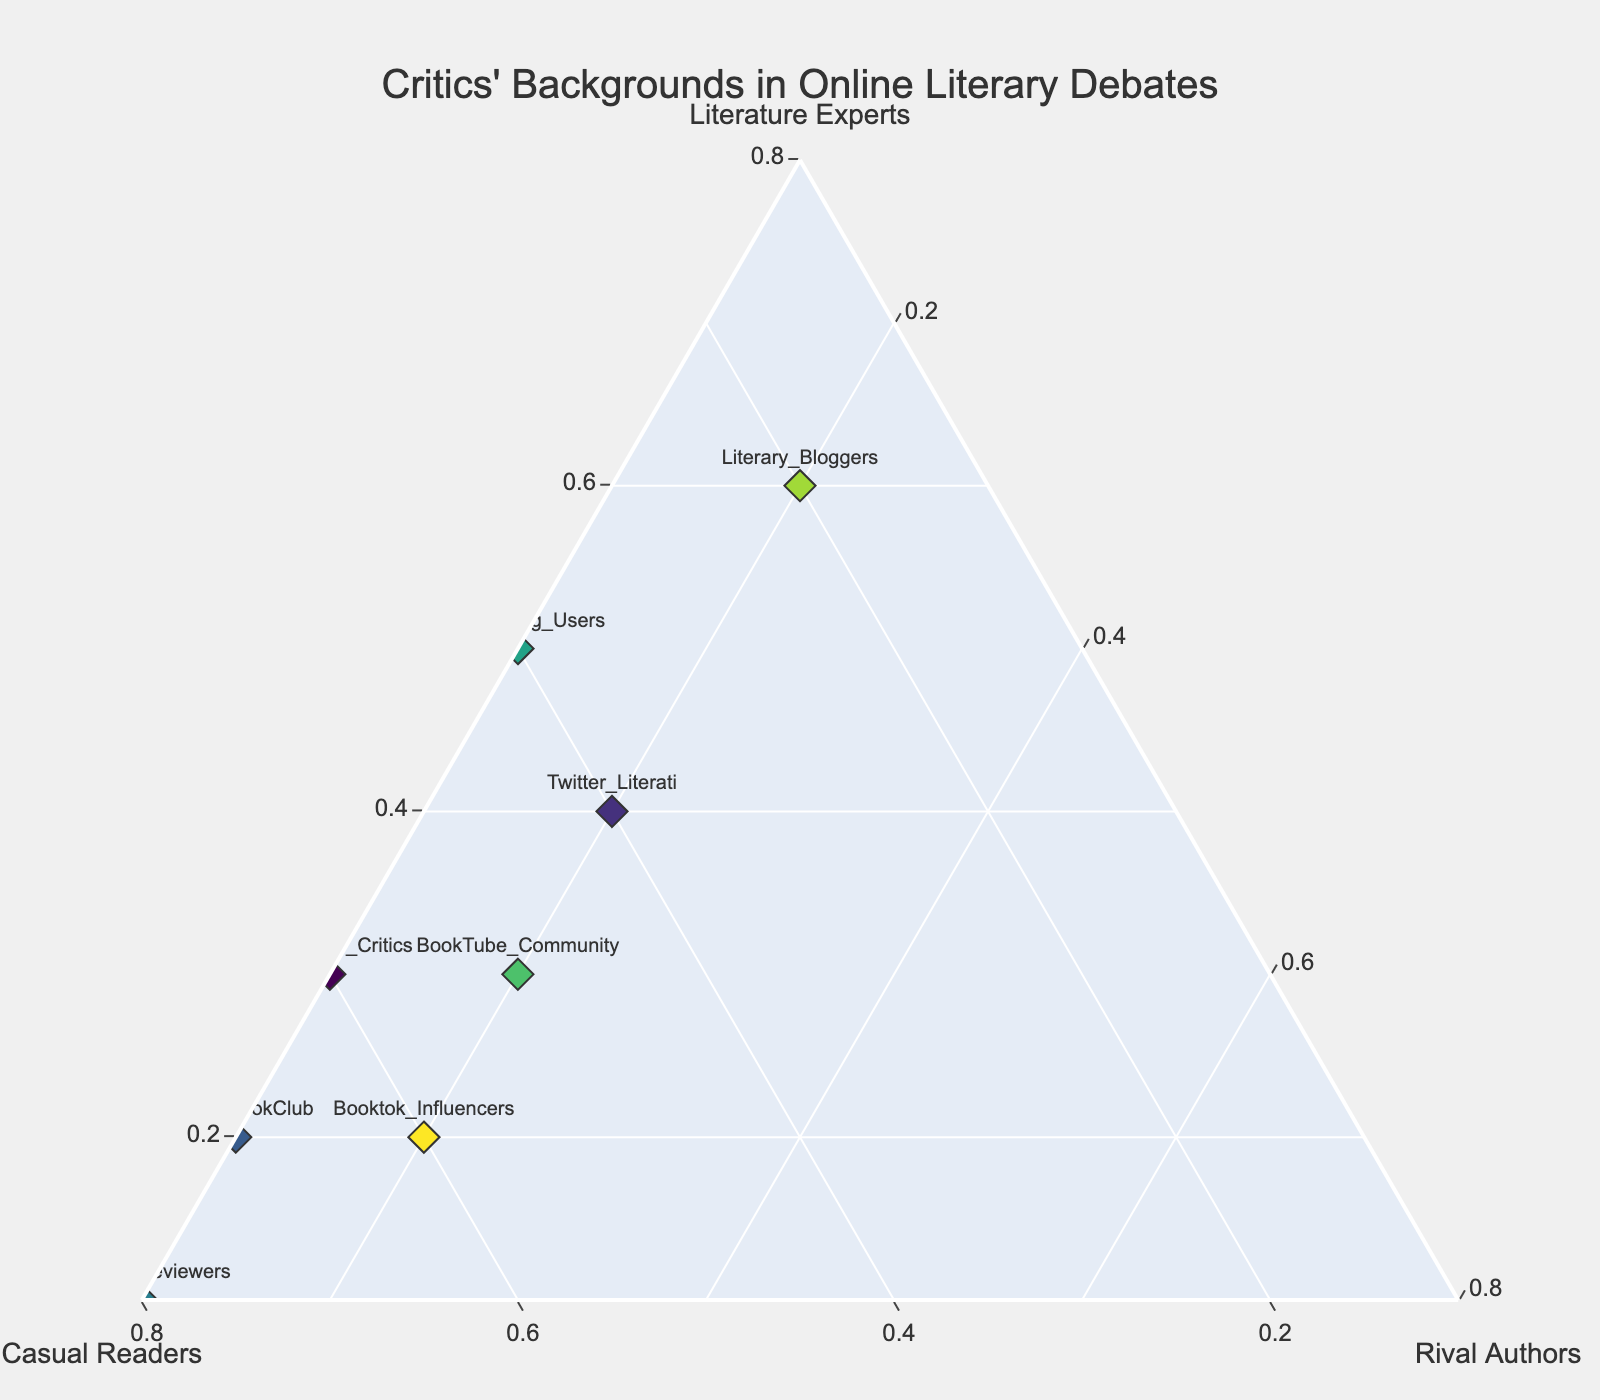What is the title of the plot? The title of the plot is usually displayed prominently at the top of the figure.
Answer: Critics' Backgrounds in Online Literary Debates Which group has the highest proportion of Literature Experts? To determine this, check the 'Literature Experts' axis and look for the group name closest to the maximum value.
Answer: Literary_Bloggers How many groups have more than 0.3 in Literature Experts? Identify and count the groups whose markers are positioned above the 0.3 proportion line on the 'Literature Experts' axis.
Answer: 3 (Twitter_Literati, LibraryThing_Users, Literary_Bloggers) Which groups have an equal proportion of Casual Readers? Check the 'Casual Readers' axis and find multiple groups aligned at the same value.
Answer: Twitter_Literati and LibraryThing_Users What is the range of values for Rival Authors across all groups? Identify the minimum and maximum values on the 'Rival Authors' axis by locating the points closest and furthest from the origin.
Answer: 0.1 to 0.2 List the groups in descending order based on Casual Readers proportion. Compare the proportion of Casual Readers for each group and arrange them from highest to lowest.
Answer: Amazon_Reviewers, Reddit_BookClub, Booktok_Influencers, Goodreads_Critics, BookTube_Community, Twitter_Literati, LibraryThing_Users, Literary_Bloggers Which group has the lowest proportion of Literature Experts but the highest proportion of Casual Readers? Identify the group at the minimum on the 'Literature Experts' axis, and verify if it has the highest on the 'Casual Readers' axis.
Answer: Amazon_Reviewers Is there any group with an equal proportion of all three backgrounds? Check if any group's marker lies at a balanced position within the ternary plot stemming equally from all three axes.
Answer: No, none of the groups have equal proportions What combination of critics' backgrounds are most similar among the listed groups? Evaluate the proximity among points considering the relative positioning of proportions for all three backgrounds.
Answer: Goodreads_Critics and Booktok_Influencers Which group stands out with a high Literature Experts but low Casual Readers and Rival Authors proportion? Look for the group with a marker close to the maximum on the 'Literature Experts' axis and minimums on the 'Casual Readers' and 'Rival Authors' axes.
Answer: Literary_Bloggers 